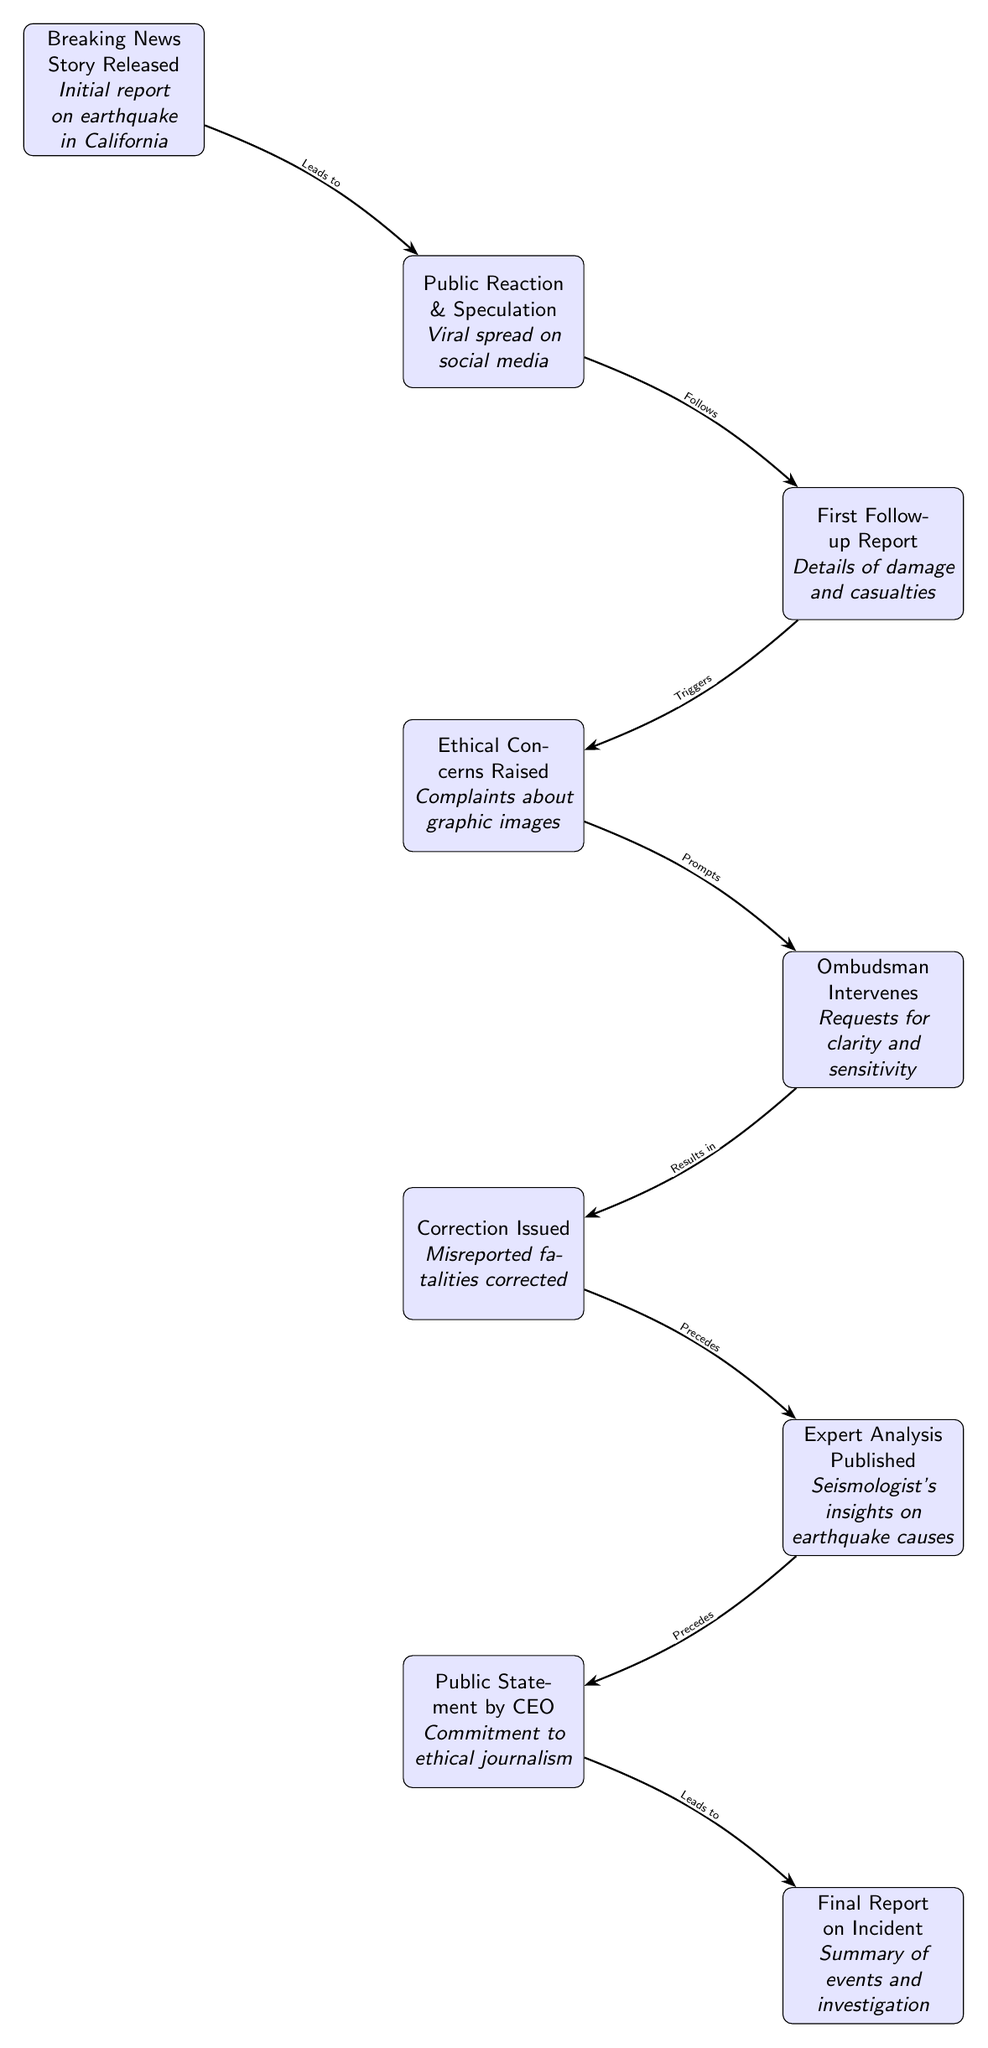What is the first event in the timeline? The first event in the timeline is the "Breaking News Story Released", which provides the initial report on the earthquake in California.
Answer: Breaking News Story Released How many main events are depicted in the diagram? There are a total of eight main events represented in the diagram, enumerating from the breaking news to the final report on the incident.
Answer: Eight Which event follows the "Public Reaction & Speculation"? The event that follows "Public Reaction & Speculation" is the "First Follow-up Report", which details the damage and casualties.
Answer: First Follow-up Report What prompts the ombudsman intervention? The ombudsman intervention is prompted by the "Ethical Concerns Raised", specifically regarding complaints about graphic images.
Answer: Ethical Concerns Raised What results from the ombudsman intervention? The result of the ombudsman intervention is a "Correction Issued", which addresses the misreported fatalities.
Answer: Correction Issued How does the final report relate to the public statement by the CEO? The "Final Report on Incident" is preceded by the "Public Statement by CEO", which demonstrates the commitment to ethical journalism.
Answer: Precedes What is the relationship between the first follow-up report and the ethical concerns raised? The relationship is that the first follow-up report triggers the "Ethical Concerns Raised" regarding graphic images.
Answer: Triggers What was the focus of the "Expert Analysis Published"? The focus of the "Expert Analysis Published" is on the seismologist's insights regarding the causes of the earthquake.
Answer: Seismologist's insights on earthquake causes 